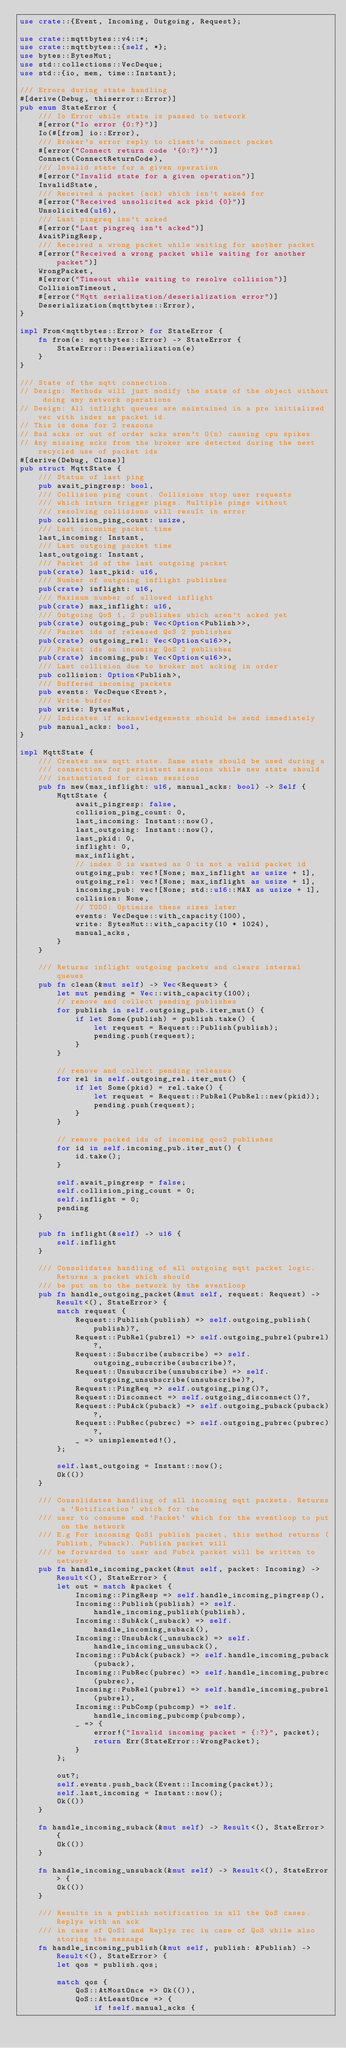Convert code to text. <code><loc_0><loc_0><loc_500><loc_500><_Rust_>use crate::{Event, Incoming, Outgoing, Request};

use crate::mqttbytes::v4::*;
use crate::mqttbytes::{self, *};
use bytes::BytesMut;
use std::collections::VecDeque;
use std::{io, mem, time::Instant};

/// Errors during state handling
#[derive(Debug, thiserror::Error)]
pub enum StateError {
    /// Io Error while state is passed to network
    #[error("Io error {0:?}")]
    Io(#[from] io::Error),
    /// Broker's error reply to client's connect packet
    #[error("Connect return code `{0:?}`")]
    Connect(ConnectReturnCode),
    /// Invalid state for a given operation
    #[error("Invalid state for a given operation")]
    InvalidState,
    /// Received a packet (ack) which isn't asked for
    #[error("Received unsolicited ack pkid {0}")]
    Unsolicited(u16),
    /// Last pingreq isn't acked
    #[error("Last pingreq isn't acked")]
    AwaitPingResp,
    /// Received a wrong packet while waiting for another packet
    #[error("Received a wrong packet while waiting for another packet")]
    WrongPacket,
    #[error("Timeout while waiting to resolve collision")]
    CollisionTimeout,
    #[error("Mqtt serialization/deserialization error")]
    Deserialization(mqttbytes::Error),
}

impl From<mqttbytes::Error> for StateError {
    fn from(e: mqttbytes::Error) -> StateError {
        StateError::Deserialization(e)
    }
}

/// State of the mqtt connection.
// Design: Methods will just modify the state of the object without doing any network operations
// Design: All inflight queues are maintained in a pre initialized vec with index as packet id.
// This is done for 2 reasons
// Bad acks or out of order acks aren't O(n) causing cpu spikes
// Any missing acks from the broker are detected during the next recycled use of packet ids
#[derive(Debug, Clone)]
pub struct MqttState {
    /// Status of last ping
    pub await_pingresp: bool,
    /// Collision ping count. Collisions stop user requests
    /// which inturn trigger pings. Multiple pings without
    /// resolving collisions will result in error
    pub collision_ping_count: usize,
    /// Last incoming packet time
    last_incoming: Instant,
    /// Last outgoing packet time
    last_outgoing: Instant,
    /// Packet id of the last outgoing packet
    pub(crate) last_pkid: u16,
    /// Number of outgoing inflight publishes
    pub(crate) inflight: u16,
    /// Maximum number of allowed inflight
    pub(crate) max_inflight: u16,
    /// Outgoing QoS 1, 2 publishes which aren't acked yet
    pub(crate) outgoing_pub: Vec<Option<Publish>>,
    /// Packet ids of released QoS 2 publishes
    pub(crate) outgoing_rel: Vec<Option<u16>>,
    /// Packet ids on incoming QoS 2 publishes
    pub(crate) incoming_pub: Vec<Option<u16>>,
    /// Last collision due to broker not acking in order
    pub collision: Option<Publish>,
    /// Buffered incoming packets
    pub events: VecDeque<Event>,
    /// Write buffer
    pub write: BytesMut,
    /// Indicates if acknowledgements should be send immediately
    pub manual_acks: bool,
}

impl MqttState {
    /// Creates new mqtt state. Same state should be used during a
    /// connection for persistent sessions while new state should
    /// instantiated for clean sessions
    pub fn new(max_inflight: u16, manual_acks: bool) -> Self {
        MqttState {
            await_pingresp: false,
            collision_ping_count: 0,
            last_incoming: Instant::now(),
            last_outgoing: Instant::now(),
            last_pkid: 0,
            inflight: 0,
            max_inflight,
            // index 0 is wasted as 0 is not a valid packet id
            outgoing_pub: vec![None; max_inflight as usize + 1],
            outgoing_rel: vec![None; max_inflight as usize + 1],
            incoming_pub: vec![None; std::u16::MAX as usize + 1],
            collision: None,
            // TODO: Optimize these sizes later
            events: VecDeque::with_capacity(100),
            write: BytesMut::with_capacity(10 * 1024),
            manual_acks,
        }
    }

    /// Returns inflight outgoing packets and clears internal queues
    pub fn clean(&mut self) -> Vec<Request> {
        let mut pending = Vec::with_capacity(100);
        // remove and collect pending publishes
        for publish in self.outgoing_pub.iter_mut() {
            if let Some(publish) = publish.take() {
                let request = Request::Publish(publish);
                pending.push(request);
            }
        }

        // remove and collect pending releases
        for rel in self.outgoing_rel.iter_mut() {
            if let Some(pkid) = rel.take() {
                let request = Request::PubRel(PubRel::new(pkid));
                pending.push(request);
            }
        }

        // remove packed ids of incoming qos2 publishes
        for id in self.incoming_pub.iter_mut() {
            id.take();
        }

        self.await_pingresp = false;
        self.collision_ping_count = 0;
        self.inflight = 0;
        pending
    }

    pub fn inflight(&self) -> u16 {
        self.inflight
    }

    /// Consolidates handling of all outgoing mqtt packet logic. Returns a packet which should
    /// be put on to the network by the eventloop
    pub fn handle_outgoing_packet(&mut self, request: Request) -> Result<(), StateError> {
        match request {
            Request::Publish(publish) => self.outgoing_publish(publish)?,
            Request::PubRel(pubrel) => self.outgoing_pubrel(pubrel)?,
            Request::Subscribe(subscribe) => self.outgoing_subscribe(subscribe)?,
            Request::Unsubscribe(unsubscribe) => self.outgoing_unsubscribe(unsubscribe)?,
            Request::PingReq => self.outgoing_ping()?,
            Request::Disconnect => self.outgoing_disconnect()?,
            Request::PubAck(puback) => self.outgoing_puback(puback)?,
            Request::PubRec(pubrec) => self.outgoing_pubrec(pubrec)?,
            _ => unimplemented!(),
        };

        self.last_outgoing = Instant::now();
        Ok(())
    }

    /// Consolidates handling of all incoming mqtt packets. Returns a `Notification` which for the
    /// user to consume and `Packet` which for the eventloop to put on the network
    /// E.g For incoming QoS1 publish packet, this method returns (Publish, Puback). Publish packet will
    /// be forwarded to user and Pubck packet will be written to network
    pub fn handle_incoming_packet(&mut self, packet: Incoming) -> Result<(), StateError> {
        let out = match &packet {
            Incoming::PingResp => self.handle_incoming_pingresp(),
            Incoming::Publish(publish) => self.handle_incoming_publish(publish),
            Incoming::SubAck(_suback) => self.handle_incoming_suback(),
            Incoming::UnsubAck(_unsuback) => self.handle_incoming_unsuback(),
            Incoming::PubAck(puback) => self.handle_incoming_puback(puback),
            Incoming::PubRec(pubrec) => self.handle_incoming_pubrec(pubrec),
            Incoming::PubRel(pubrel) => self.handle_incoming_pubrel(pubrel),
            Incoming::PubComp(pubcomp) => self.handle_incoming_pubcomp(pubcomp),
            _ => {
                error!("Invalid incoming packet = {:?}", packet);
                return Err(StateError::WrongPacket);
            }
        };

        out?;
        self.events.push_back(Event::Incoming(packet));
        self.last_incoming = Instant::now();
        Ok(())
    }

    fn handle_incoming_suback(&mut self) -> Result<(), StateError> {
        Ok(())
    }

    fn handle_incoming_unsuback(&mut self) -> Result<(), StateError> {
        Ok(())
    }

    /// Results in a publish notification in all the QoS cases. Replys with an ack
    /// in case of QoS1 and Replys rec in case of QoS while also storing the message
    fn handle_incoming_publish(&mut self, publish: &Publish) -> Result<(), StateError> {
        let qos = publish.qos;

        match qos {
            QoS::AtMostOnce => Ok(()),
            QoS::AtLeastOnce => {
                if !self.manual_acks {</code> 